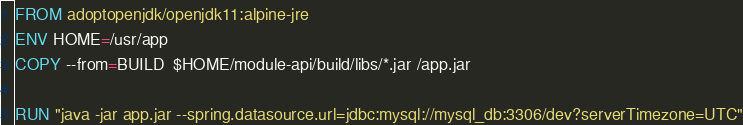<code> <loc_0><loc_0><loc_500><loc_500><_Dockerfile_>FROM adoptopenjdk/openjdk11:alpine-jre
ENV HOME=/usr/app
COPY --from=BUILD  $HOME/module-api/build/libs/*.jar /app.jar

RUN "java -jar app.jar --spring.datasource.url=jdbc:mysql://mysql_db:3306/dev?serverTimezone=UTC"</code> 